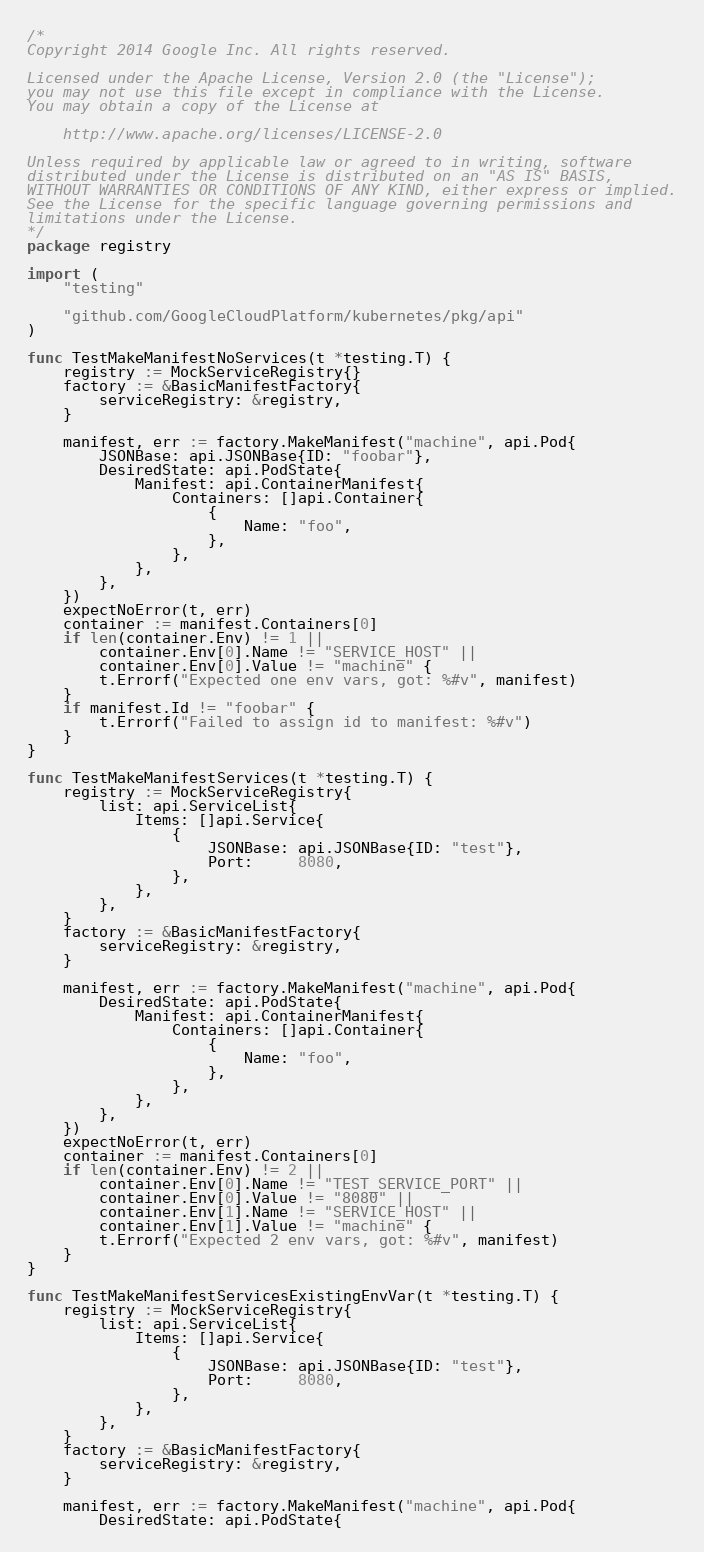Convert code to text. <code><loc_0><loc_0><loc_500><loc_500><_Go_>/*
Copyright 2014 Google Inc. All rights reserved.

Licensed under the Apache License, Version 2.0 (the "License");
you may not use this file except in compliance with the License.
You may obtain a copy of the License at

    http://www.apache.org/licenses/LICENSE-2.0

Unless required by applicable law or agreed to in writing, software
distributed under the License is distributed on an "AS IS" BASIS,
WITHOUT WARRANTIES OR CONDITIONS OF ANY KIND, either express or implied.
See the License for the specific language governing permissions and
limitations under the License.
*/
package registry

import (
	"testing"

	"github.com/GoogleCloudPlatform/kubernetes/pkg/api"
)

func TestMakeManifestNoServices(t *testing.T) {
	registry := MockServiceRegistry{}
	factory := &BasicManifestFactory{
		serviceRegistry: &registry,
	}

	manifest, err := factory.MakeManifest("machine", api.Pod{
		JSONBase: api.JSONBase{ID: "foobar"},
		DesiredState: api.PodState{
			Manifest: api.ContainerManifest{
				Containers: []api.Container{
					{
						Name: "foo",
					},
				},
			},
		},
	})
	expectNoError(t, err)
	container := manifest.Containers[0]
	if len(container.Env) != 1 ||
		container.Env[0].Name != "SERVICE_HOST" ||
		container.Env[0].Value != "machine" {
		t.Errorf("Expected one env vars, got: %#v", manifest)
	}
	if manifest.Id != "foobar" {
		t.Errorf("Failed to assign id to manifest: %#v")
	}
}

func TestMakeManifestServices(t *testing.T) {
	registry := MockServiceRegistry{
		list: api.ServiceList{
			Items: []api.Service{
				{
					JSONBase: api.JSONBase{ID: "test"},
					Port:     8080,
				},
			},
		},
	}
	factory := &BasicManifestFactory{
		serviceRegistry: &registry,
	}

	manifest, err := factory.MakeManifest("machine", api.Pod{
		DesiredState: api.PodState{
			Manifest: api.ContainerManifest{
				Containers: []api.Container{
					{
						Name: "foo",
					},
				},
			},
		},
	})
	expectNoError(t, err)
	container := manifest.Containers[0]
	if len(container.Env) != 2 ||
		container.Env[0].Name != "TEST_SERVICE_PORT" ||
		container.Env[0].Value != "8080" ||
		container.Env[1].Name != "SERVICE_HOST" ||
		container.Env[1].Value != "machine" {
		t.Errorf("Expected 2 env vars, got: %#v", manifest)
	}
}

func TestMakeManifestServicesExistingEnvVar(t *testing.T) {
	registry := MockServiceRegistry{
		list: api.ServiceList{
			Items: []api.Service{
				{
					JSONBase: api.JSONBase{ID: "test"},
					Port:     8080,
				},
			},
		},
	}
	factory := &BasicManifestFactory{
		serviceRegistry: &registry,
	}

	manifest, err := factory.MakeManifest("machine", api.Pod{
		DesiredState: api.PodState{</code> 